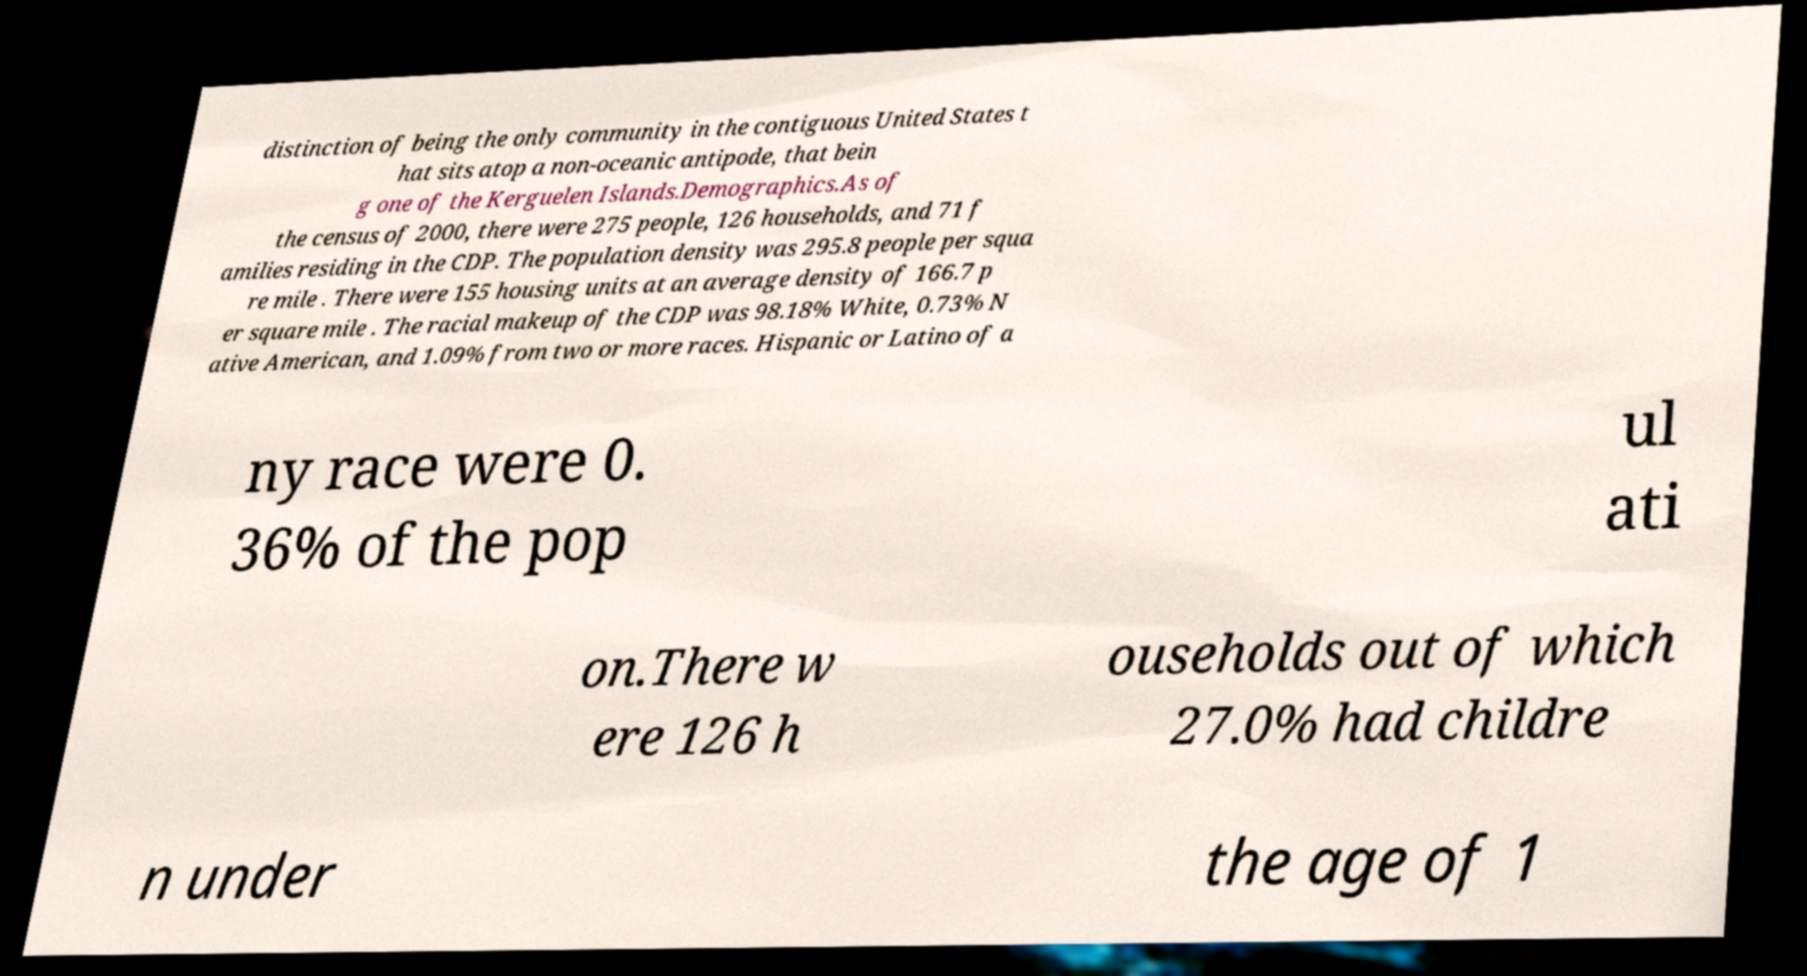Can you read and provide the text displayed in the image?This photo seems to have some interesting text. Can you extract and type it out for me? distinction of being the only community in the contiguous United States t hat sits atop a non-oceanic antipode, that bein g one of the Kerguelen Islands.Demographics.As of the census of 2000, there were 275 people, 126 households, and 71 f amilies residing in the CDP. The population density was 295.8 people per squa re mile . There were 155 housing units at an average density of 166.7 p er square mile . The racial makeup of the CDP was 98.18% White, 0.73% N ative American, and 1.09% from two or more races. Hispanic or Latino of a ny race were 0. 36% of the pop ul ati on.There w ere 126 h ouseholds out of which 27.0% had childre n under the age of 1 